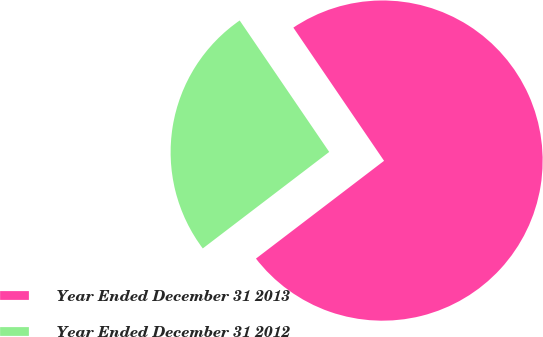Convert chart to OTSL. <chart><loc_0><loc_0><loc_500><loc_500><pie_chart><fcel>Year Ended December 31 2013<fcel>Year Ended December 31 2012<nl><fcel>74.14%<fcel>25.86%<nl></chart> 